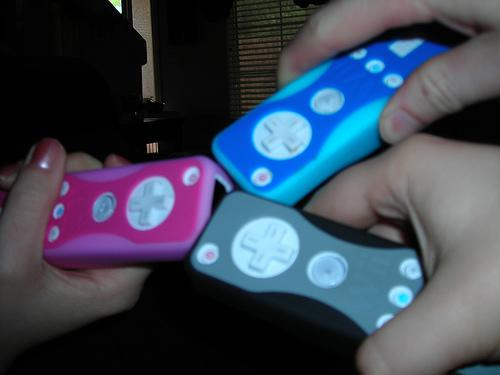Question: how many remotes are there?
Choices:
A. Two.
B. Three.
C. One.
D. Four.
Answer with the letter. Answer: B Question: what are the holding?
Choices:
A. Wii remotes.
B. Leashes.
C. Sticks.
D. Chain.
Answer with the letter. Answer: A Question: who is holding the remote on the left?
Choices:
A. The one with pink fingernail polish on.
B. The girl in blue.
C. The overweight man.
D. A surgeon.
Answer with the letter. Answer: A Question: where is the blue remote?
Choices:
A. On bottom.
B. The left.
C. The right.
D. On the top.
Answer with the letter. Answer: D Question: where is the table?
Choices:
A. In front of the pink remote.
B. Behind the pink remote.
C. In a pile.
D. In the dumpster.
Answer with the letter. Answer: B Question: what color fingernail polish is there?
Choices:
A. Pink.
B. Blue.
C. Red.
D. Gold.
Answer with the letter. Answer: A 